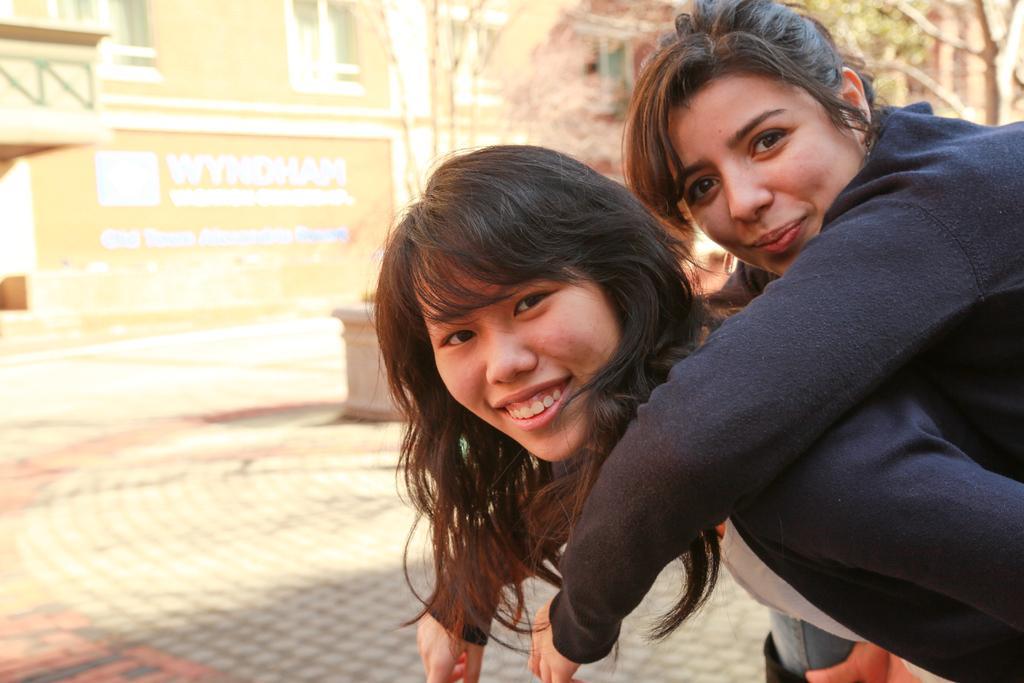Please provide a concise description of this image. In the image there are two women on the left side in sweatshirts, both of them are smiling, on the left side there is a building with trees in front of it. 